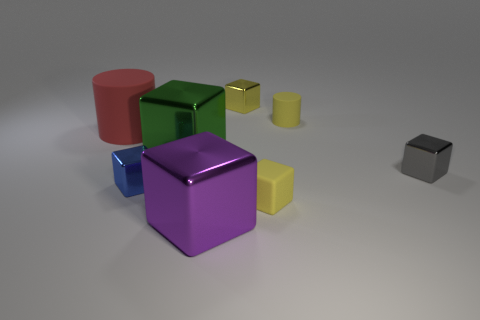What material is the other block that is the same color as the small rubber cube?
Give a very brief answer. Metal. What material is the big purple object that is the same shape as the large green shiny object?
Provide a succinct answer. Metal. What number of large purple balls are there?
Your answer should be compact. 0. There is a metallic thing that is on the right side of the small cylinder; what is its shape?
Your response must be concise. Cube. What color is the large metallic object behind the small object left of the large metal thing left of the big purple cube?
Your answer should be very brief. Green. What is the shape of the other large object that is the same material as the large purple object?
Provide a succinct answer. Cube. Are there fewer cubes than tiny red cubes?
Keep it short and to the point. No. Does the yellow cylinder have the same material as the large purple block?
Offer a terse response. No. What number of other things are there of the same color as the big cylinder?
Ensure brevity in your answer.  0. Is the number of big blue balls greater than the number of cylinders?
Provide a short and direct response. No. 